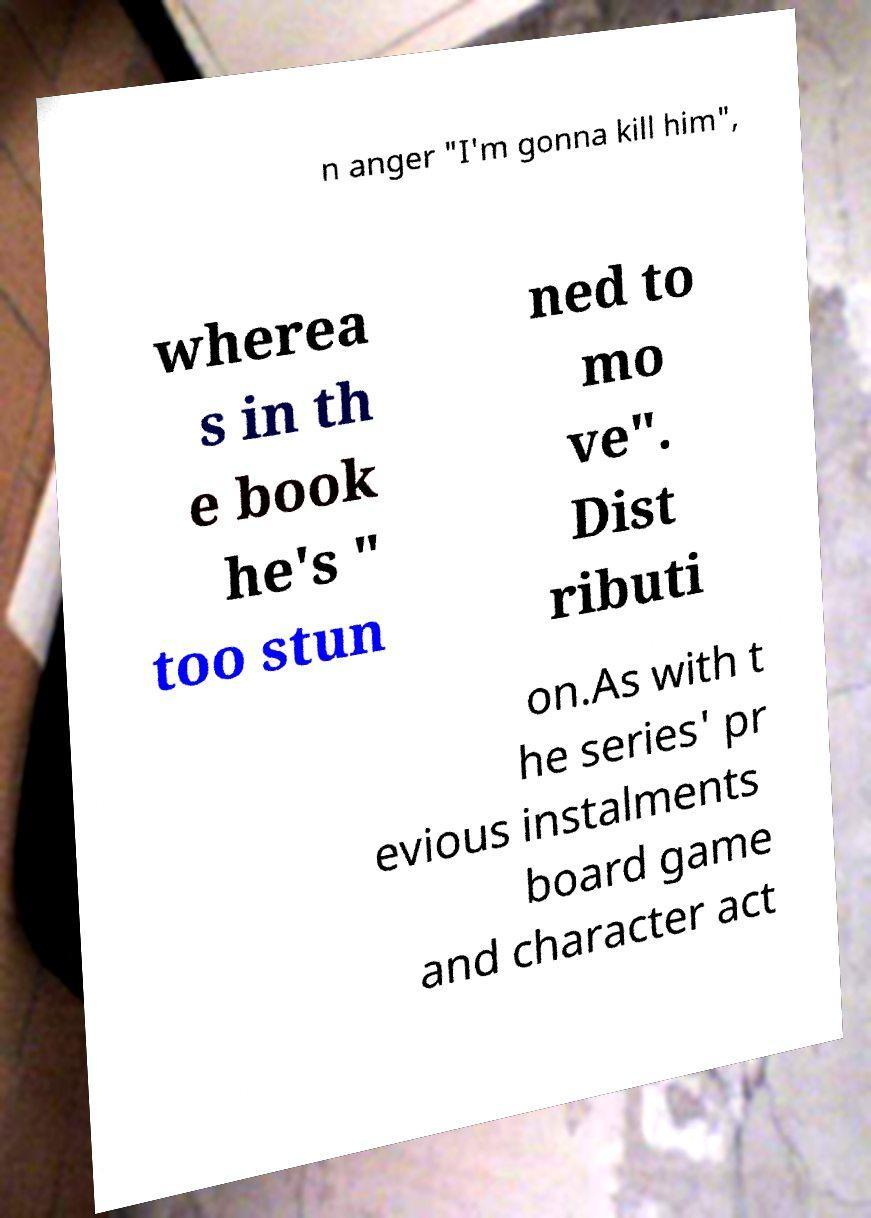For documentation purposes, I need the text within this image transcribed. Could you provide that? n anger "I'm gonna kill him", wherea s in th e book he's " too stun ned to mo ve". Dist ributi on.As with t he series' pr evious instalments board game and character act 